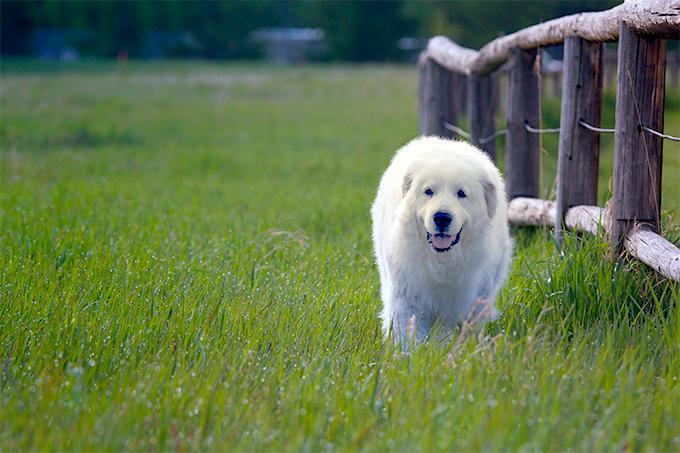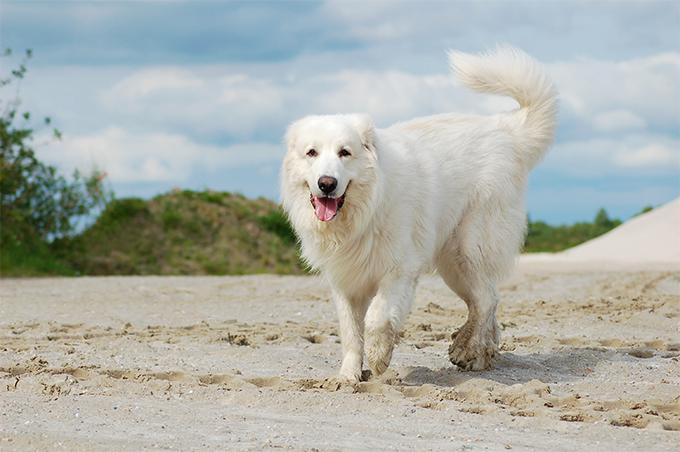The first image is the image on the left, the second image is the image on the right. For the images shown, is this caption "Exactly two large white dogs are standing upright." true? Answer yes or no. Yes. The first image is the image on the left, the second image is the image on the right. Evaluate the accuracy of this statement regarding the images: "There are only two dogs and both are standing with at least one of them on green grass.". Is it true? Answer yes or no. Yes. 